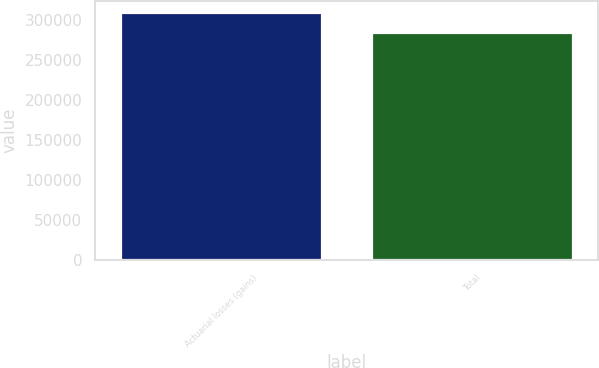Convert chart to OTSL. <chart><loc_0><loc_0><loc_500><loc_500><bar_chart><fcel>Actuarial losses (gains)<fcel>Total<nl><fcel>308230<fcel>284035<nl></chart> 